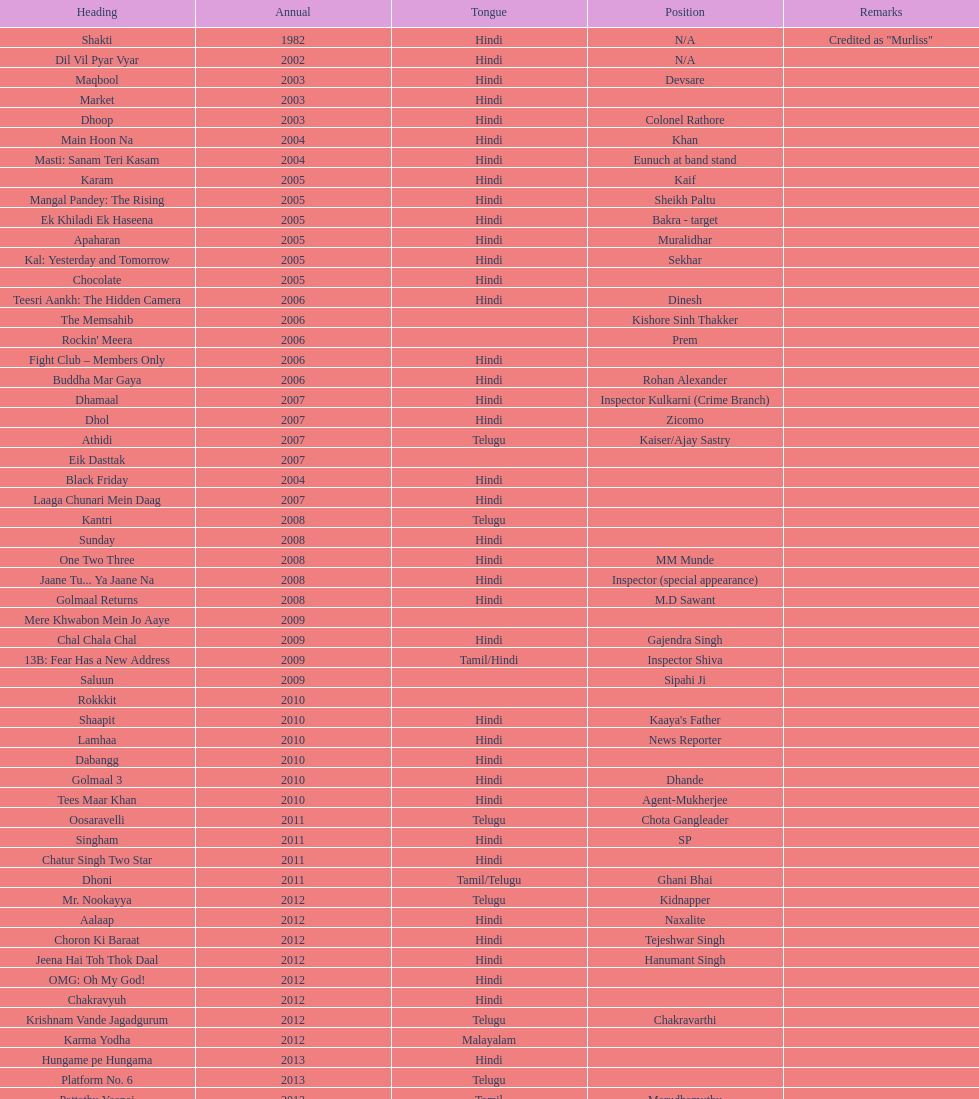What was the subsequent film for this actor after their 2002 performance in dil vil pyar vyar? Maqbool. 